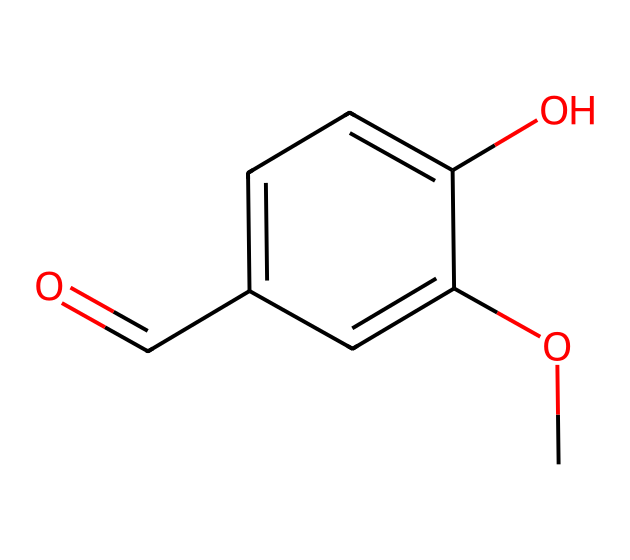What is the molecular formula of vanillin? To determine the molecular formula, we can count the atoms of each element present in the structure based on the SMILES representation. Here, we find: 8 carbon (C), 8 hydrogen (H), and 3 oxygen (O) atoms. Therefore, the molecular formula is C8H8O3.
Answer: C8H8O3 How many rings are present in the structure of vanillin? Analyzing the structure from the SMILES notation, we see no occurrences of ring structures, as there are no connections indicating cyclic forms. This implies that vanillin does not have any rings.
Answer: 0 Which functional groups are identified in vanillin? From the structure, we can identify the presence of an aldehyde (-C=O), a hydroxyl group (-OH), and a methoxy group (-OCH3). These functional groups contribute to the chemical properties of vanillin.
Answer: aldehyde, hydroxyl, methoxy What type of compound is vanillin classified as? The structure indicates that vanillin contains both aromatic elements and multiple functional groups without any nitrogen atoms. It is thus classified under the category of aromatic aldehydes.
Answer: aromatic aldehyde Does vanillin have any double bonds in its structure? By examining the SMILES representation closely, we observe that there is a double bond between a carbon and an oxygen atom in the aldehyde group (C=O) and a double bond in the aromatic ring (C=C). This confirms the presence of double bonds.
Answer: yes How many total oxygen atoms are in vanillin's structure? By reviewing the molecular structure based on the SMILES, we count three oxygen atoms present in both the functional groups and the aromatic character. Thus, the total number of oxygen atoms is three.
Answer: 3 